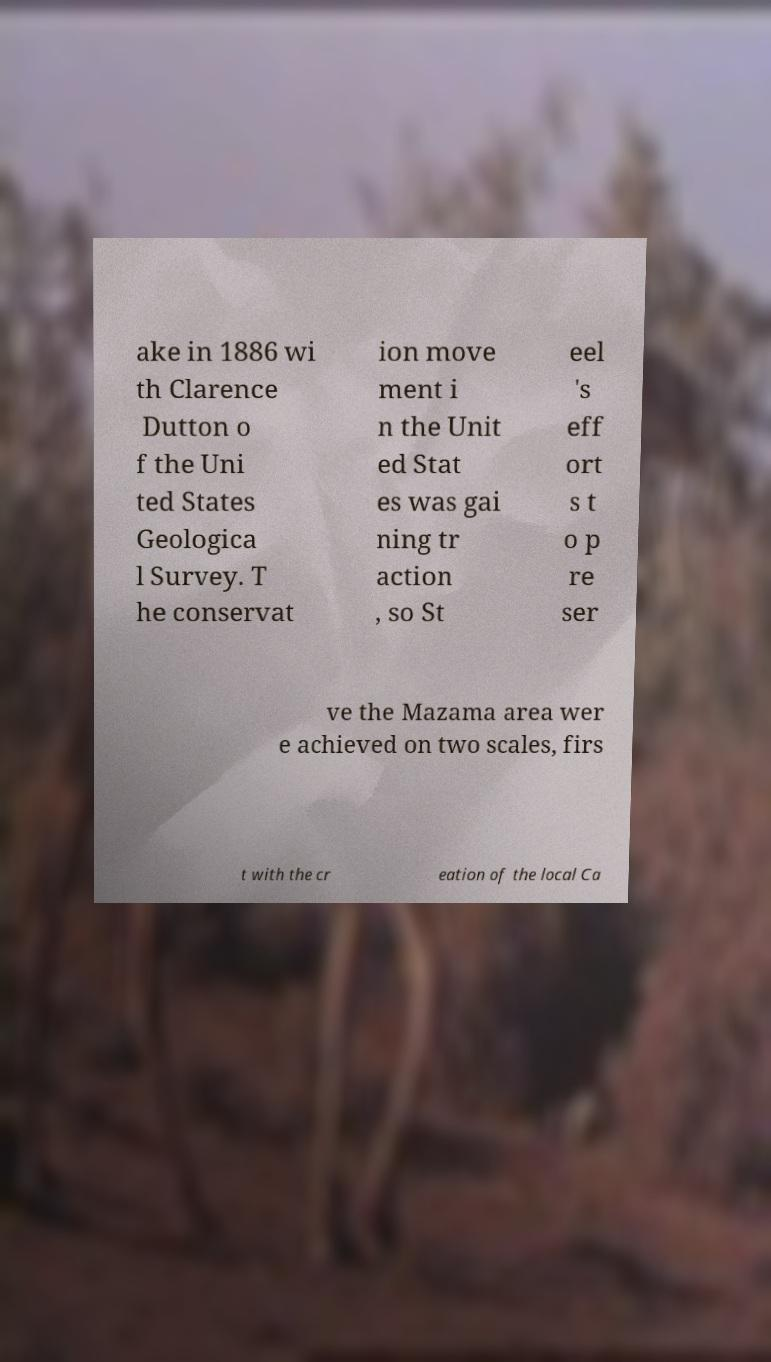Can you accurately transcribe the text from the provided image for me? ake in 1886 wi th Clarence Dutton o f the Uni ted States Geologica l Survey. T he conservat ion move ment i n the Unit ed Stat es was gai ning tr action , so St eel 's eff ort s t o p re ser ve the Mazama area wer e achieved on two scales, firs t with the cr eation of the local Ca 